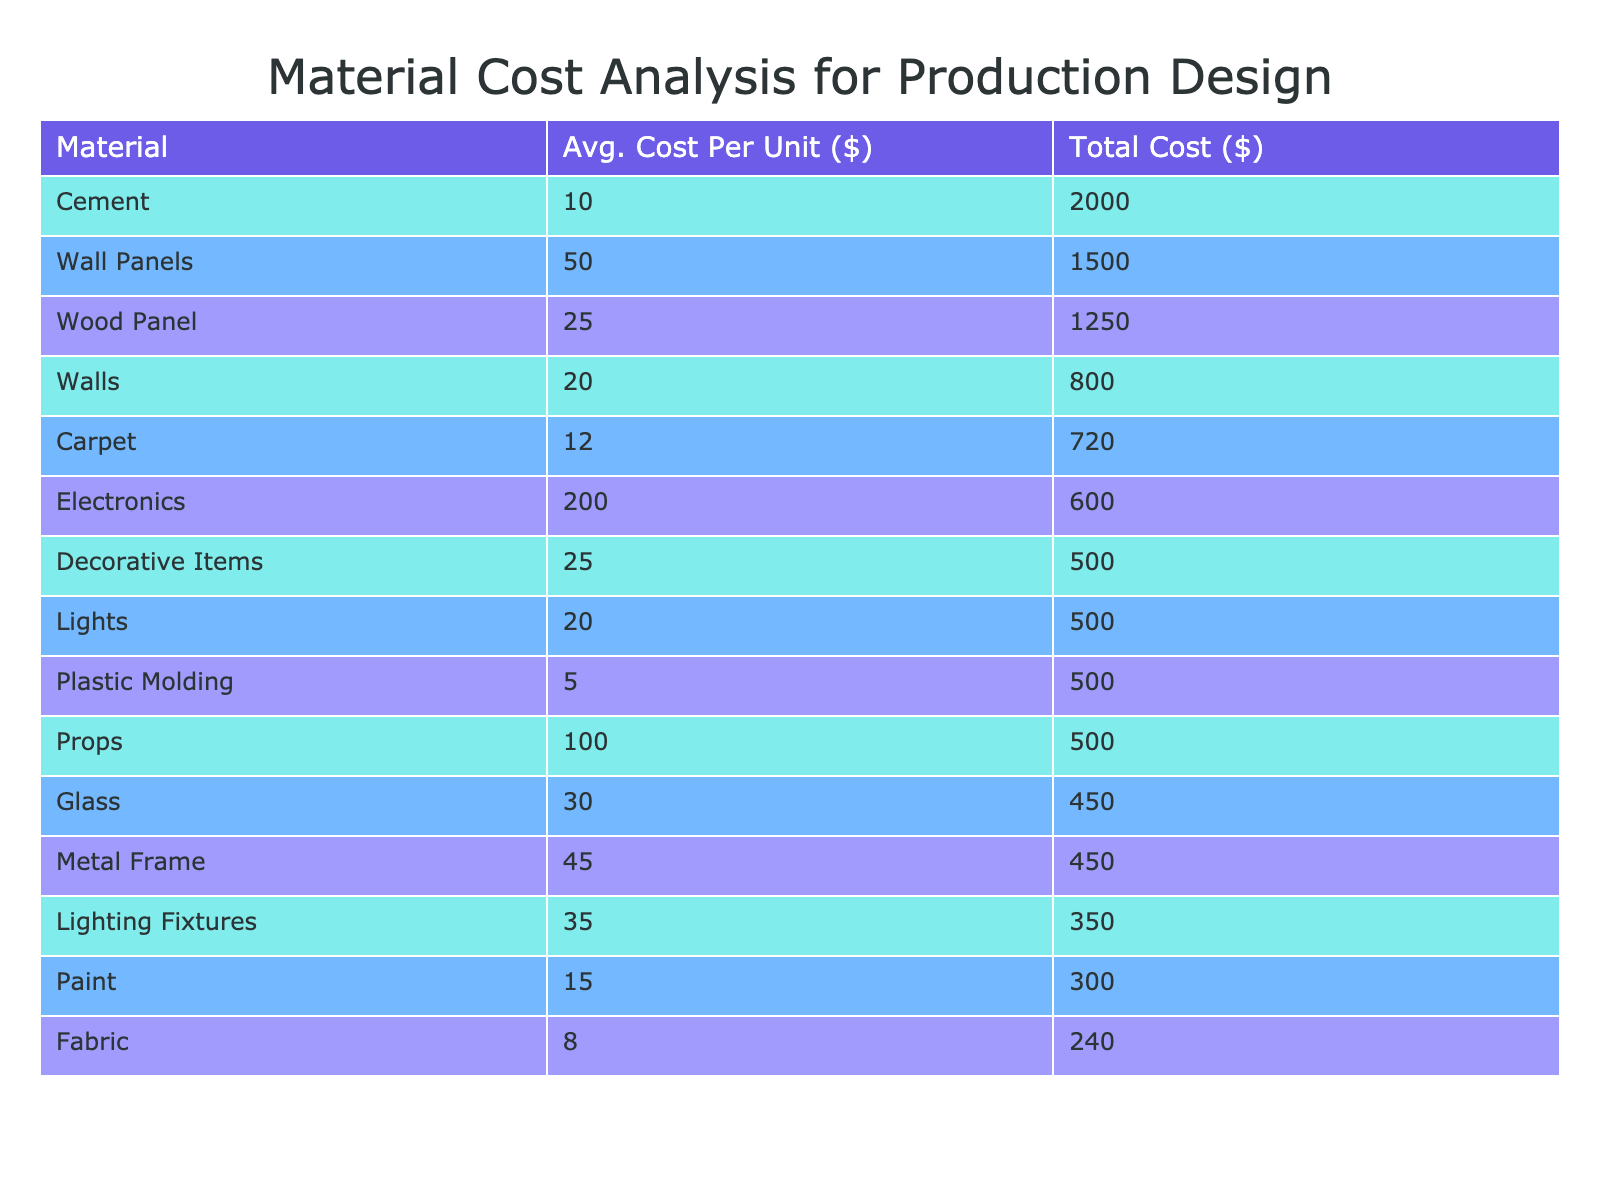What is the total cost of Paint across all projects? The total cost of Paint comes from Project A only, where it has a total cost of 300 USD. Since there are no other entries for Paint in other projects, the total remains 300.
Answer: 300 Which material has the highest average cost per unit? Reviewing the table, the materials and their average costs per unit show that Electronics has the highest unit cost at 200 USD.
Answer: 200 Is there a material in Project D with a total cost exceeding 700 USD? Looking at the costs for Project D, Carpet has a total cost of 720 USD, Props costs 500 USD, and Electronics costs 600 USD. Therefore, yes, Carpet exceeds 700.
Answer: Yes What is the average total cost of materials used in Project E? Project E has three materials with total costs of 2000 USD, 1500 USD, and 500 USD. To find the average, sum these costs (2000 + 1500 + 500 = 4000) and divide by the number of materials (3). Thus, the average total cost is 4000 / 3 = 1333.33.
Answer: 1333.33 How much does Fabric cost relative to the total material costs of Project A? In Project A, the total material costs sum to 1250 + 300 + 240 = 1790 USD. Fabric has a total cost of 240 USD, so we can find the relative amount by calculating (240 / 1790) * 100, which gives us approximately 13.4%.
Answer: 13.4% Which project has the lowest total cost across all materials? Evaluating the total costs for each project: Project A is 1790 USD, Project B is 1400 USD, Project C is 1650 USD, Project D is 1820 USD, and Project E is 4000 USD. Project B has the lowest total cost of 1400 USD.
Answer: Project B What is the combined total cost of materials used in Projects A and B? For Project A, the total cost is 1790 USD, and for Project B, it is 1400 USD. Adding these amounts gives us 1790 + 1400 = 3190 USD, showing the combined total cost of materials used in both projects.
Answer: 3190 Is the total cost of Walls and Lighting Fixtures together greater than that of Cement? The total cost of Walls is 800 USD and Lighting Fixtures is 350 USD, which sums to 1150 USD. Cement has a total cost of 2000 USD. Since 1150 is less than 2000, it is false that together they exceed Cement's cost.
Answer: No What is the total quantity of all materials used in Project C? Project C uses Plastic Molding (100 units), Lighting Fixtures (10 units), and Walls (40 units). To find the total quantity, we add these units together: 100 + 10 + 40 = 150 units.
Answer: 150 